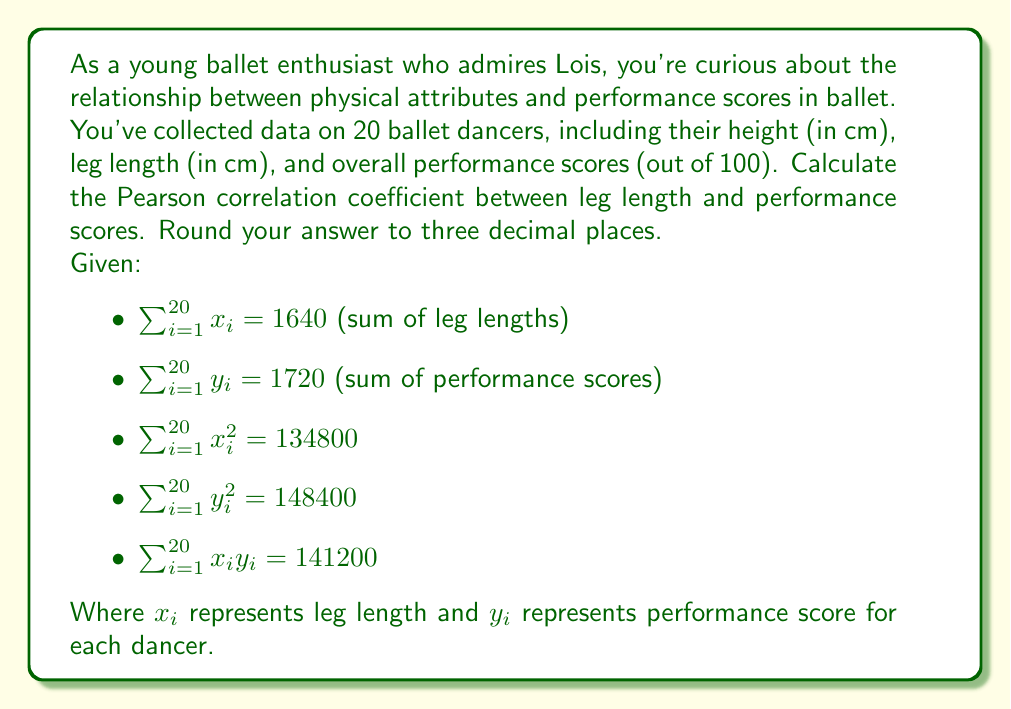Provide a solution to this math problem. To calculate the Pearson correlation coefficient $(r)$ between leg length and performance scores, we'll use the formula:

$$r = \frac{n\sum x_iy_i - (\sum x_i)(\sum y_i)}{\sqrt{[n\sum x_i^2 - (\sum x_i)^2][n\sum y_i^2 - (\sum y_i)^2]}}$$

Where $n$ is the number of dancers (20 in this case).

Step 1: Calculate $n\sum x_iy_i$
$20 \times 141200 = 2824000$

Step 2: Calculate $(\sum x_i)(\sum y_i)$
$1640 \times 1720 = 2820800$

Step 3: Calculate the numerator
$2824000 - 2820800 = 3200$

Step 4: Calculate $n\sum x_i^2$ and $(\sum x_i)^2$
$n\sum x_i^2 = 20 \times 134800 = 2696000$
$(\sum x_i)^2 = 1640^2 = 2689600$

Step 5: Calculate $n\sum y_i^2$ and $(\sum y_i)^2$
$n\sum y_i^2 = 20 \times 148400 = 2968000$
$(\sum y_i)^2 = 1720^2 = 2958400$

Step 6: Calculate the denominator
$\sqrt{(2696000 - 2689600)(2968000 - 2958400)}$
$= \sqrt{(6400)(9600)}$
$= \sqrt{61440000}$
$= 7840$

Step 7: Calculate the correlation coefficient
$r = \frac{3200}{7840} = 0.408163...$

Rounding to three decimal places: $0.408$
Answer: 0.408 